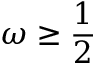<formula> <loc_0><loc_0><loc_500><loc_500>\omega \geq \frac { 1 } { 2 }</formula> 